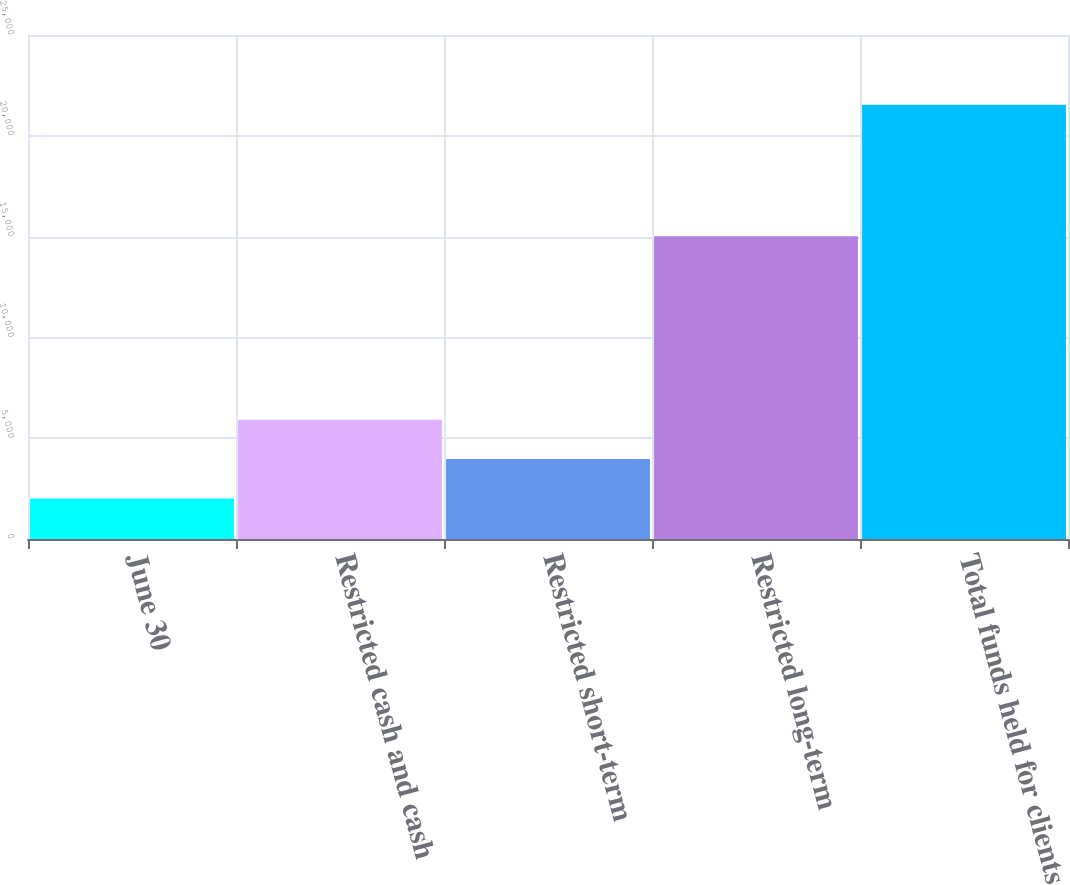Convert chart to OTSL. <chart><loc_0><loc_0><loc_500><loc_500><bar_chart><fcel>June 30<fcel>Restricted cash and cash<fcel>Restricted short-term<fcel>Restricted long-term<fcel>Total funds held for clients<nl><fcel>2012<fcel>5917.42<fcel>3964.71<fcel>15022<fcel>21539.1<nl></chart> 